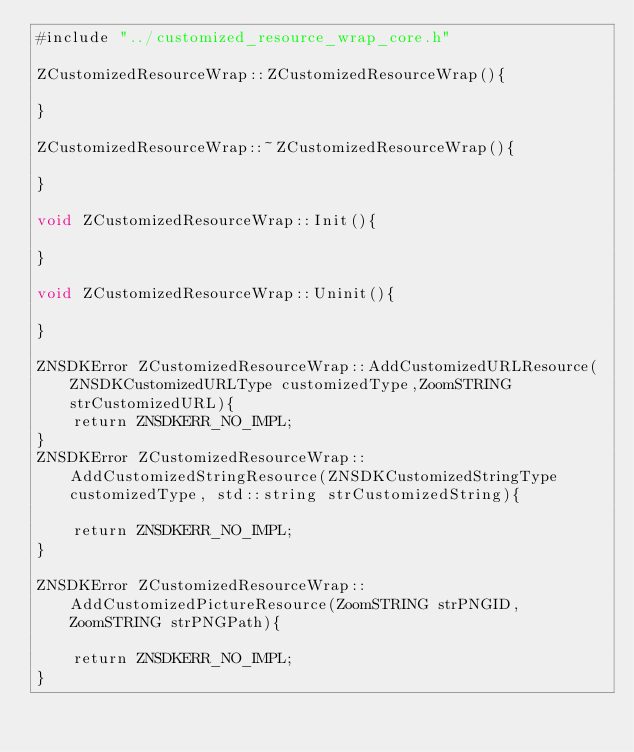<code> <loc_0><loc_0><loc_500><loc_500><_ObjectiveC_>#include "../customized_resource_wrap_core.h"

ZCustomizedResourceWrap::ZCustomizedResourceWrap(){
    
}

ZCustomizedResourceWrap::~ZCustomizedResourceWrap(){
    
}

void ZCustomizedResourceWrap::Init(){
    
}

void ZCustomizedResourceWrap::Uninit(){
    
}

ZNSDKError ZCustomizedResourceWrap::AddCustomizedURLResource(ZNSDKCustomizedURLType customizedType,ZoomSTRING strCustomizedURL){
    return ZNSDKERR_NO_IMPL;
}
ZNSDKError ZCustomizedResourceWrap::AddCustomizedStringResource(ZNSDKCustomizedStringType customizedType, std::string strCustomizedString){
    
    return ZNSDKERR_NO_IMPL;
}

ZNSDKError ZCustomizedResourceWrap::AddCustomizedPictureResource(ZoomSTRING strPNGID, ZoomSTRING strPNGPath){
    
    return ZNSDKERR_NO_IMPL;
}
</code> 